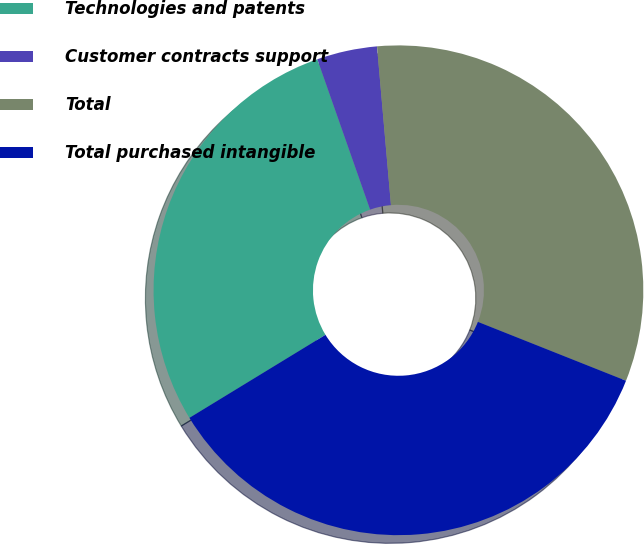<chart> <loc_0><loc_0><loc_500><loc_500><pie_chart><fcel>Technologies and patents<fcel>Customer contracts support<fcel>Total<fcel>Total purchased intangible<nl><fcel>28.35%<fcel>3.98%<fcel>32.42%<fcel>35.26%<nl></chart> 